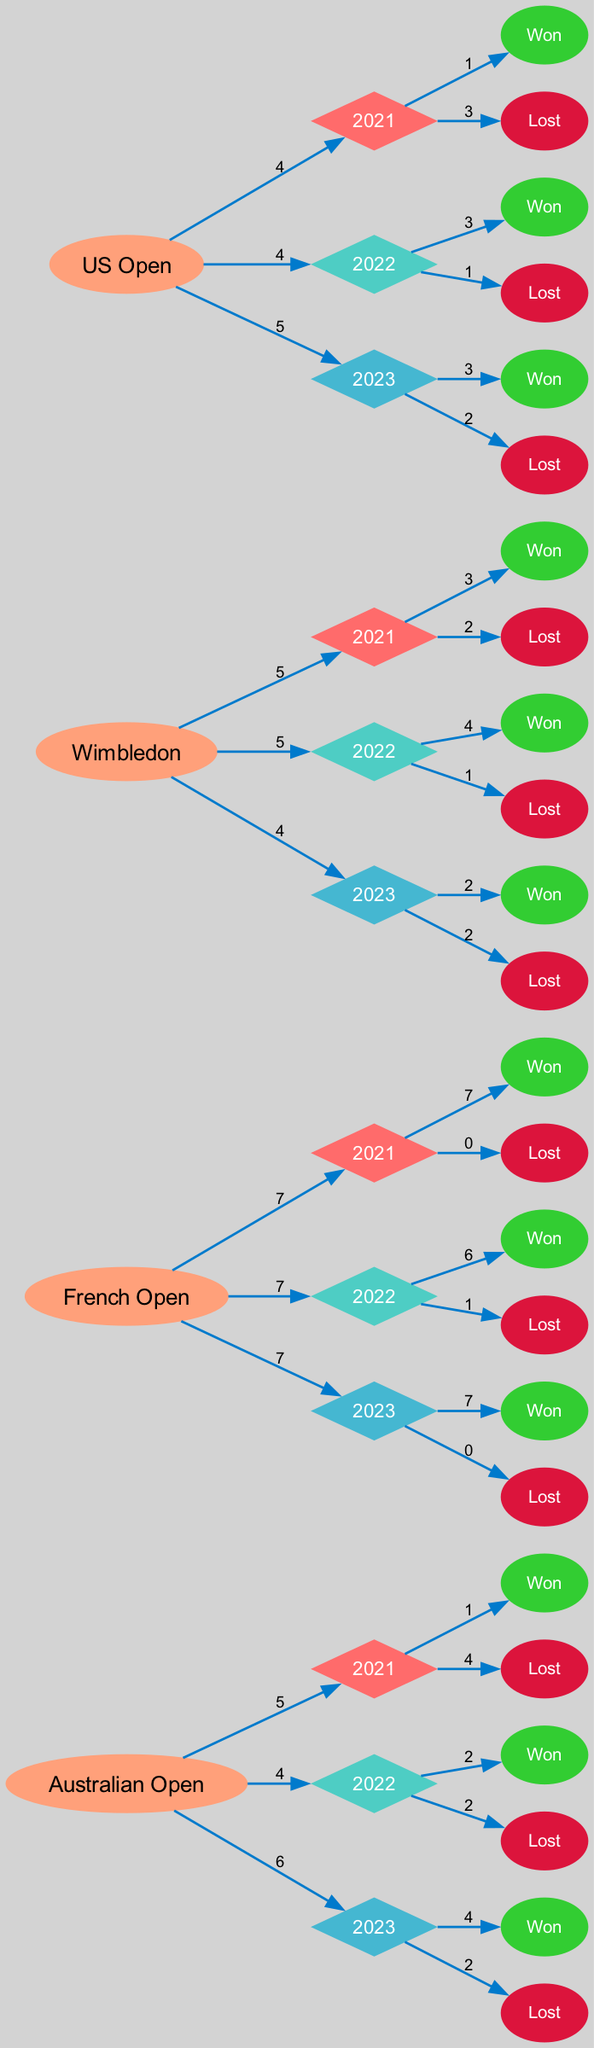What is the total number of matches Iga played in the 2022 French Open? The diagram indicates that in the 2022 French Open event, Iga played a total of 7 matches.
Answer: 7 Which year did Iga win the least number of matches in the Australian Open? By examining the nodes for the Australian Open, 2021 shows 1 win, which is the lowest compared to 2022 (2 wins) and 2023 (4 wins).
Answer: 2021 What is the outcome count for Iga's matches in 2023 at the French Open? The 2023 French Open section shows that Iga's outcomes are 7 wins and 0 losses. Thus, the total outcome count is 7 wins (as losses are 0).
Answer: 7 How many matches did Iga win across all events in 2022? To find the total wins in 2022, sum the wins from each event: Australian Open (2) + French Open (6) + Wimbledon (4) + US Open (3) = 15 wins total.
Answer: 15 Which tournament did Iga lose the most matches in 2021? The data indicates that in 2021: Australian Open (4 losses), Wimbledon (2 losses), US Open (3 losses), and French Open (0 losses). The Australian Open has the most losses.
Answer: Australian Open What is the total number of matches played by Iga in the US Open during all three years? Adding the matches: 2021 (4) + 2022 (4) + 2023 (5) gives a total of 13 matches played at the US Open across all years.
Answer: 13 In which tournament did Iga have a perfect winning streak in 2021? Looking at the data, the French Open shows 7 wins and 0 losses in 2021, indicating a perfect winning streak.
Answer: French Open What color represents the year 2022 in the diagram? The node color for the year 2022 is defined by the code as '#4ECDC4', which visually appears in the year nodes in the diagram.
Answer: #4ECDC4 How many total matches did Iga win in the 2023 tournaments combined? Summing her wins from 2023: Australian Open (4) + French Open (7) + Wimbledon (2) + US Open (3) results in a total of 16 wins.
Answer: 16 